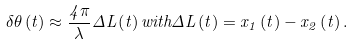<formula> <loc_0><loc_0><loc_500><loc_500>\delta \theta \left ( t \right ) \approx \frac { 4 \pi } { \lambda } \Delta L \left ( t \right ) w i t h \Delta L \left ( t \right ) = x _ { 1 } \left ( t \right ) - x _ { 2 } \left ( t \right ) .</formula> 